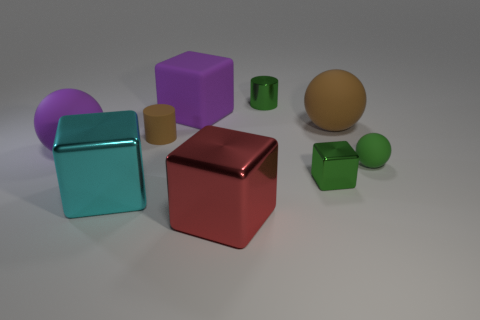What is the shape of the matte thing that is left of the tiny cylinder that is on the left side of the tiny green thing that is on the left side of the tiny block? The matte object to the left of the tiny cylinder, which in turn is to the left of the small green cube and the block, is a sphere. It has a smooth and uniform surface with no edges or vertices, typical of spherical objects. 